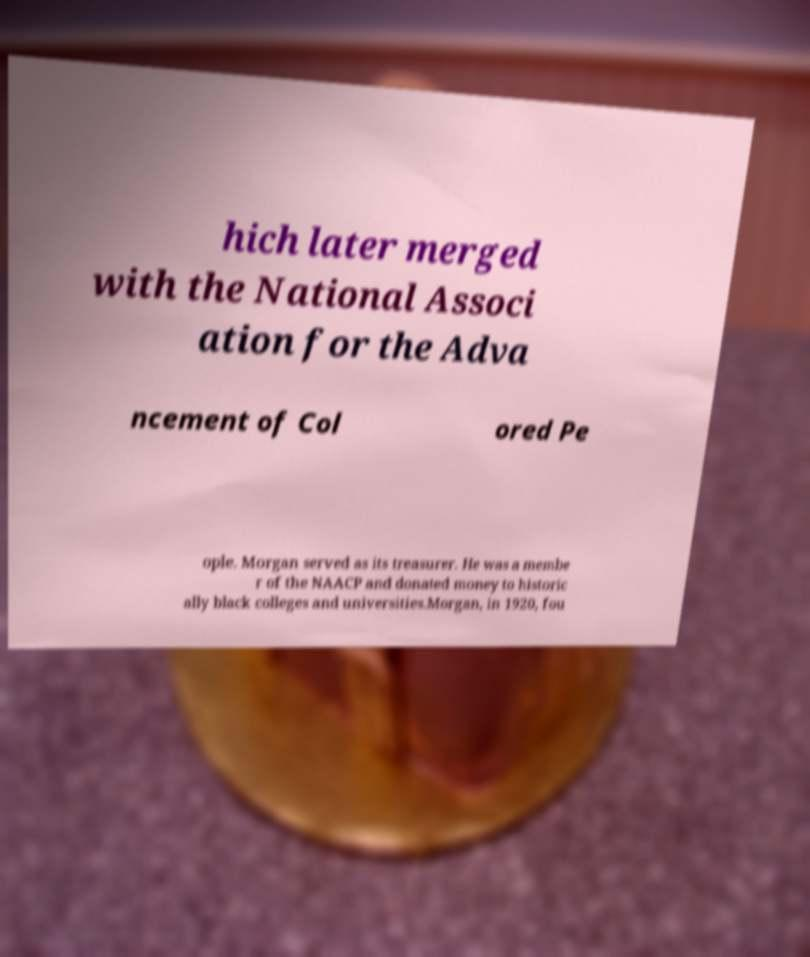There's text embedded in this image that I need extracted. Can you transcribe it verbatim? hich later merged with the National Associ ation for the Adva ncement of Col ored Pe ople. Morgan served as its treasurer. He was a membe r of the NAACP and donated money to historic ally black colleges and universities.Morgan, in 1920, fou 